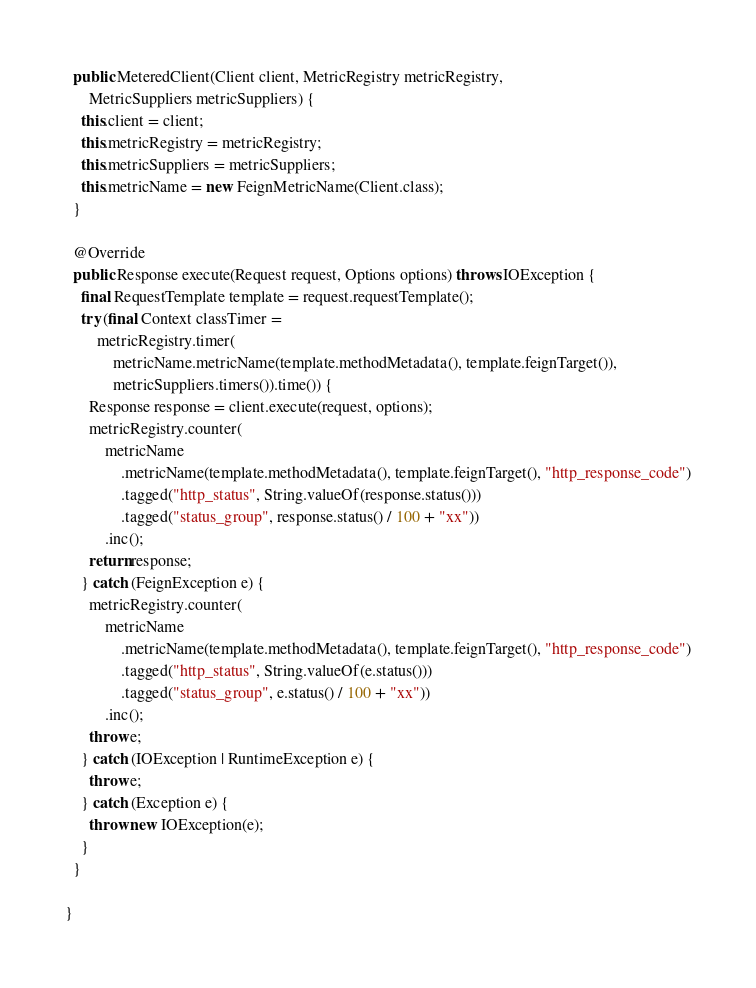<code> <loc_0><loc_0><loc_500><loc_500><_Java_>
  public MeteredClient(Client client, MetricRegistry metricRegistry,
      MetricSuppliers metricSuppliers) {
    this.client = client;
    this.metricRegistry = metricRegistry;
    this.metricSuppliers = metricSuppliers;
    this.metricName = new FeignMetricName(Client.class);
  }

  @Override
  public Response execute(Request request, Options options) throws IOException {
    final RequestTemplate template = request.requestTemplate();
    try (final Context classTimer =
        metricRegistry.timer(
            metricName.metricName(template.methodMetadata(), template.feignTarget()),
            metricSuppliers.timers()).time()) {
      Response response = client.execute(request, options);
      metricRegistry.counter(
          metricName
              .metricName(template.methodMetadata(), template.feignTarget(), "http_response_code")
              .tagged("http_status", String.valueOf(response.status()))
              .tagged("status_group", response.status() / 100 + "xx"))
          .inc();
      return response;
    } catch (FeignException e) {
      metricRegistry.counter(
          metricName
              .metricName(template.methodMetadata(), template.feignTarget(), "http_response_code")
              .tagged("http_status", String.valueOf(e.status()))
              .tagged("status_group", e.status() / 100 + "xx"))
          .inc();
      throw e;
    } catch (IOException | RuntimeException e) {
      throw e;
    } catch (Exception e) {
      throw new IOException(e);
    }
  }

}
</code> 